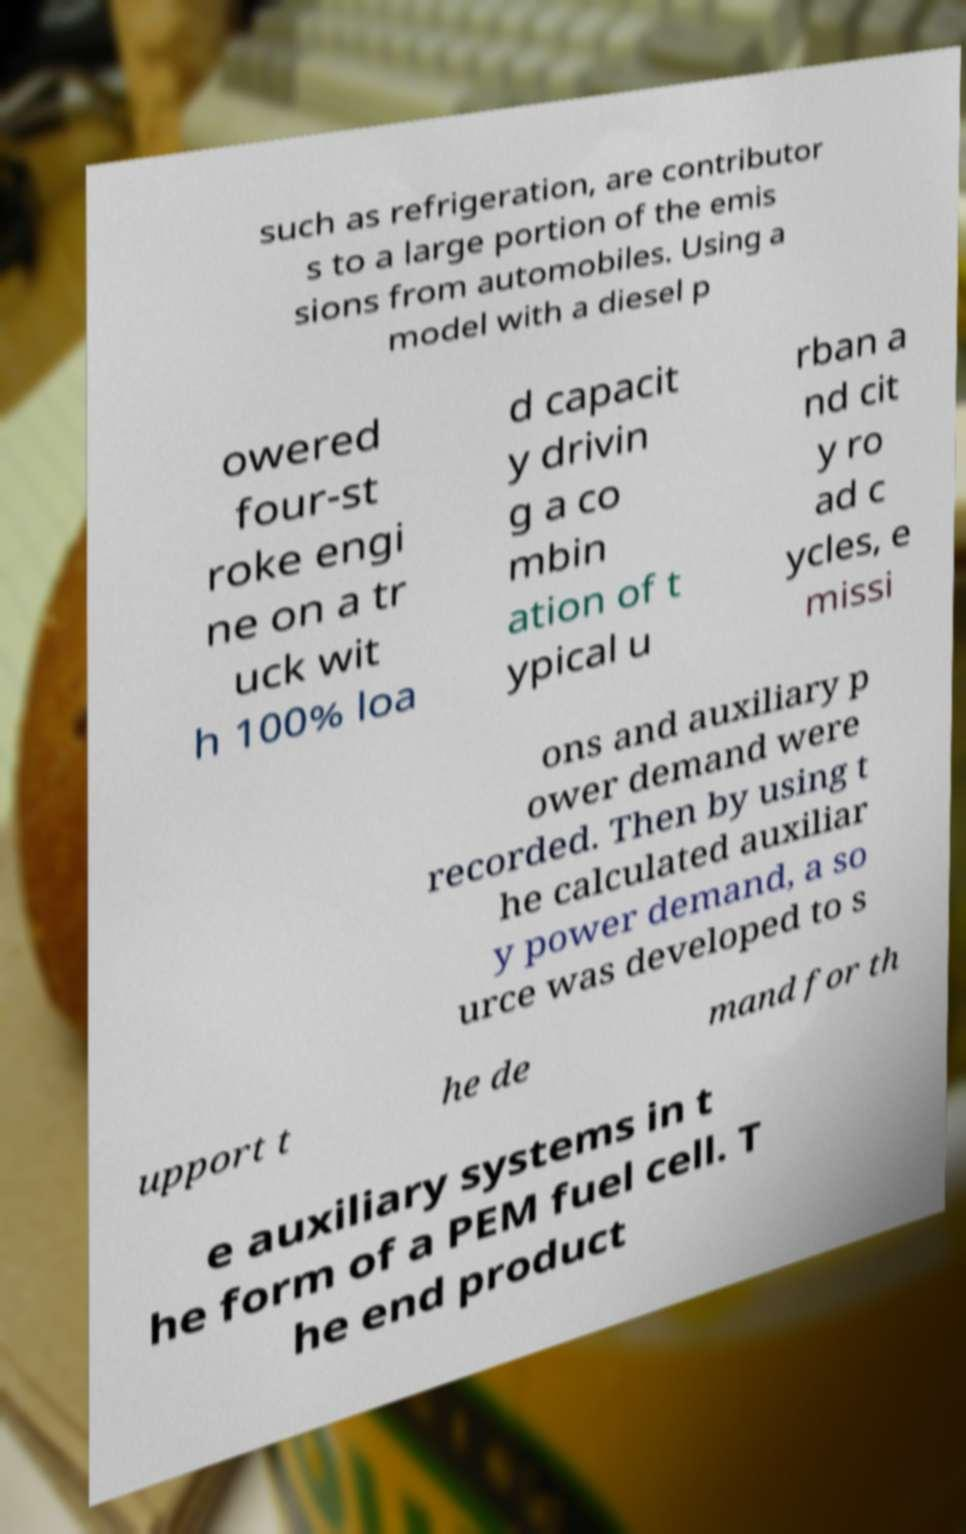Please identify and transcribe the text found in this image. such as refrigeration, are contributor s to a large portion of the emis sions from automobiles. Using a model with a diesel p owered four-st roke engi ne on a tr uck wit h 100% loa d capacit y drivin g a co mbin ation of t ypical u rban a nd cit y ro ad c ycles, e missi ons and auxiliary p ower demand were recorded. Then by using t he calculated auxiliar y power demand, a so urce was developed to s upport t he de mand for th e auxiliary systems in t he form of a PEM fuel cell. T he end product 